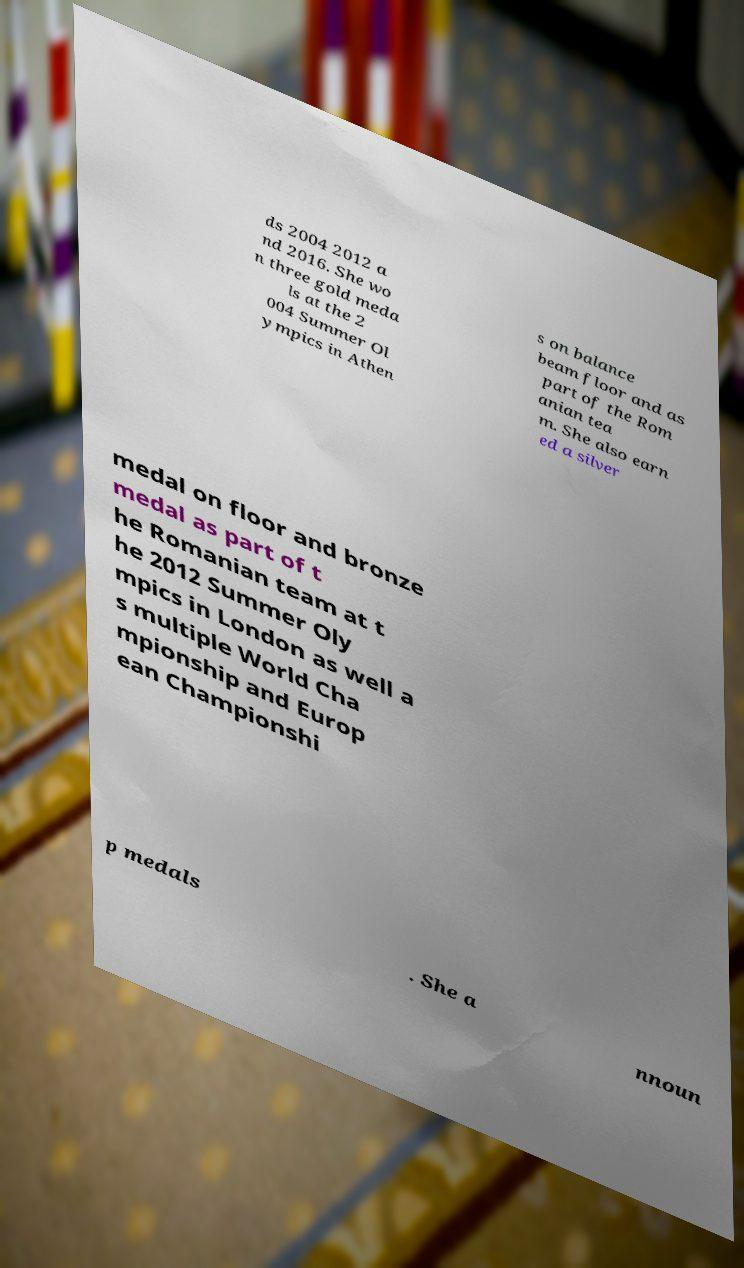Could you extract and type out the text from this image? ds 2004 2012 a nd 2016. She wo n three gold meda ls at the 2 004 Summer Ol ympics in Athen s on balance beam floor and as part of the Rom anian tea m. She also earn ed a silver medal on floor and bronze medal as part of t he Romanian team at t he 2012 Summer Oly mpics in London as well a s multiple World Cha mpionship and Europ ean Championshi p medals . She a nnoun 